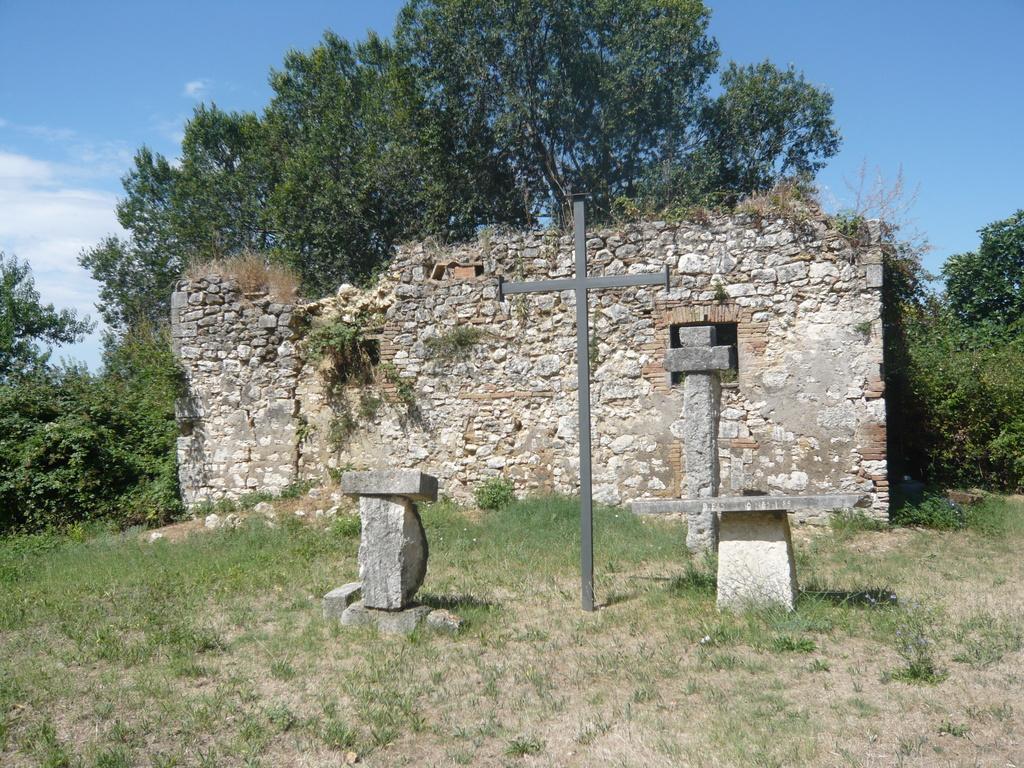Describe this image in one or two sentences. In this picture we can see there are rocks and a pole which is in the shape of a holy cross symbol. Behind the rocks there is a wall, grass, trees and the sky. 